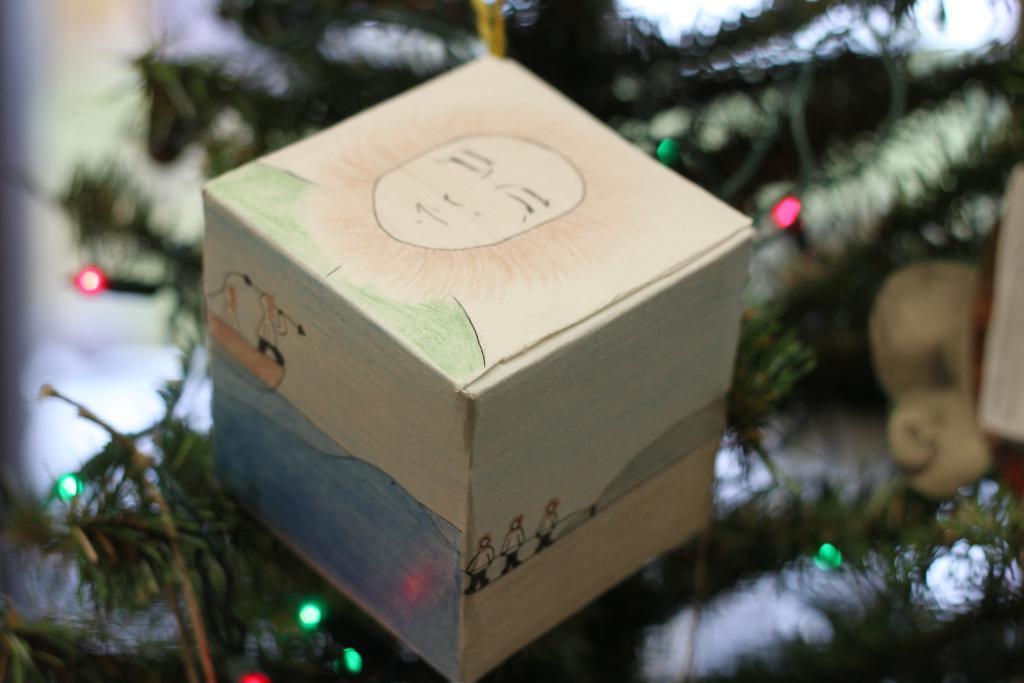Could you give a brief overview of what you see in this image? In this image there is an xmas tree and we can see a cardboard box. There are lights. 